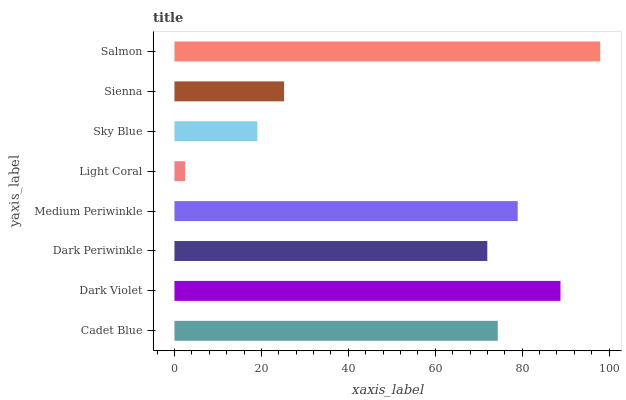Is Light Coral the minimum?
Answer yes or no. Yes. Is Salmon the maximum?
Answer yes or no. Yes. Is Dark Violet the minimum?
Answer yes or no. No. Is Dark Violet the maximum?
Answer yes or no. No. Is Dark Violet greater than Cadet Blue?
Answer yes or no. Yes. Is Cadet Blue less than Dark Violet?
Answer yes or no. Yes. Is Cadet Blue greater than Dark Violet?
Answer yes or no. No. Is Dark Violet less than Cadet Blue?
Answer yes or no. No. Is Cadet Blue the high median?
Answer yes or no. Yes. Is Dark Periwinkle the low median?
Answer yes or no. Yes. Is Light Coral the high median?
Answer yes or no. No. Is Cadet Blue the low median?
Answer yes or no. No. 